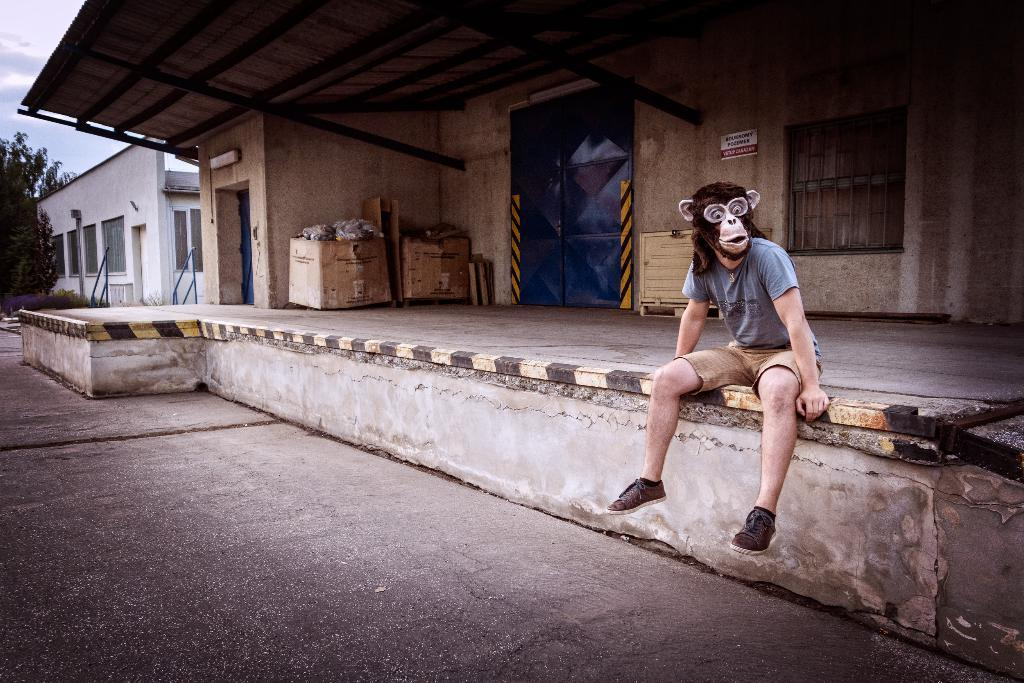What is the man in the image doing? The man is sitting in the image. What is covering the man's face? The man is wearing a mask on his face. What type of structures can be seen in the image? There are houses visible in the image. What objects are present in the image that might be used for storage or transportation? There are carton boxes in the image. What type of vegetation is visible in the image? There are trees in the image. What is the condition of the sky in the image? The sky is cloudy in the image. What type of worm can be seen crawling on the border of the image? There is no worm present in the image, and there is no border visible in the image. 